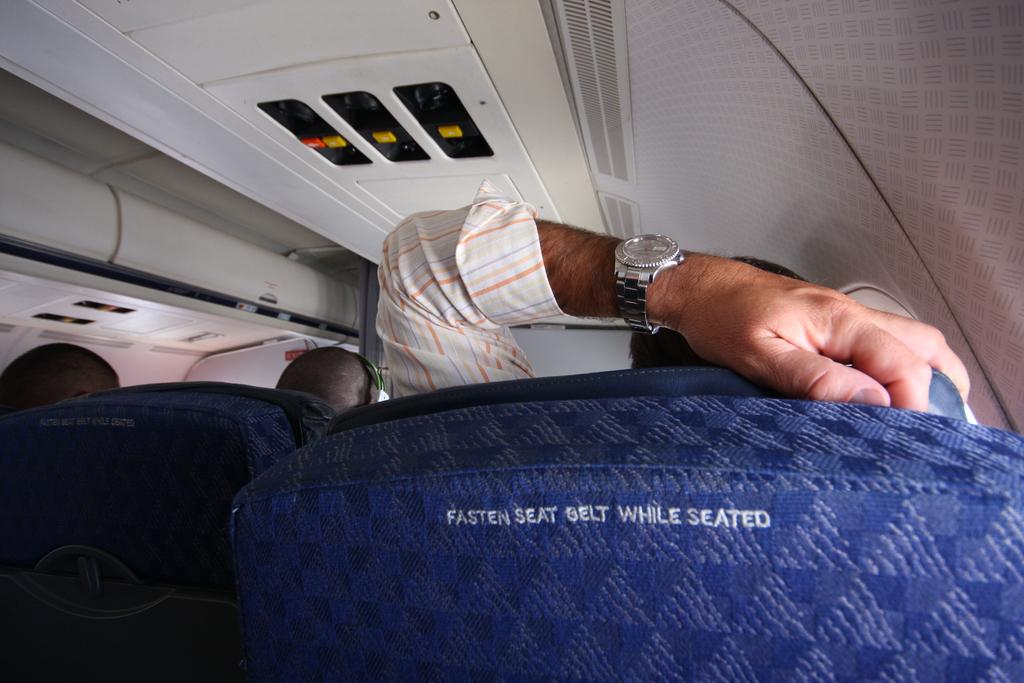What does it say on the seat in front?
Your answer should be compact. Fasten seat belt while seated. 